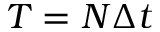<formula> <loc_0><loc_0><loc_500><loc_500>T = N \Delta t</formula> 